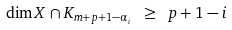<formula> <loc_0><loc_0><loc_500><loc_500>\dim X \cap K _ { m + p + 1 - \alpha _ { i } } \ \geq \ p + 1 - i</formula> 